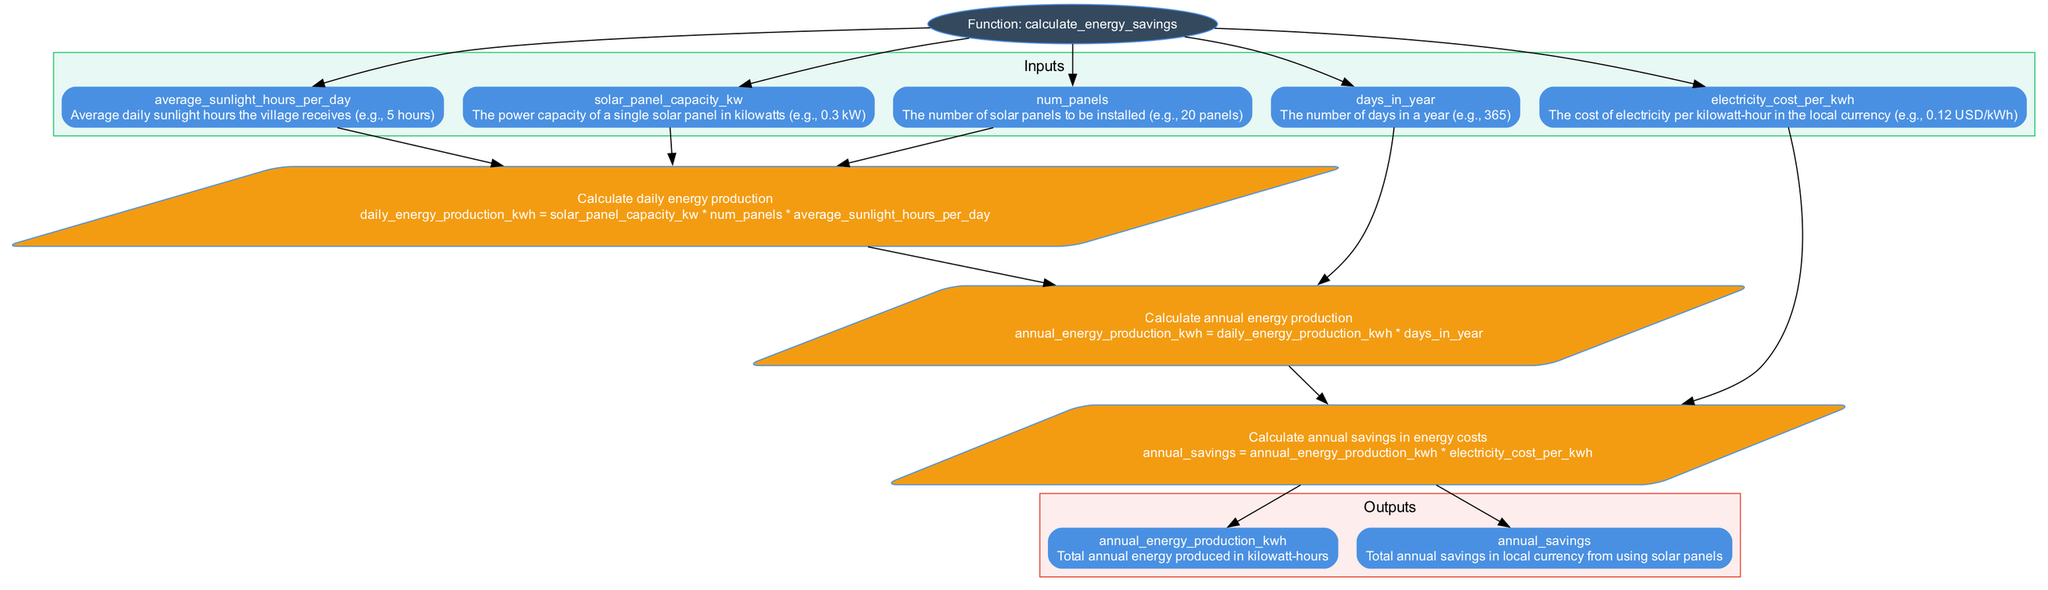What is the name of the function in the diagram? The function is named "calculate_energy_savings" as indicated in the top node of the diagram.
Answer: calculate_energy_savings How many inputs does the function have? The diagram has five input nodes listed which are solar panel capacity, number of panels, average sunlight hours per day, electricity cost per kWh, and days in a year. Therefore, the total count is five.
Answer: 5 What is the formula used to calculate daily energy production? The formula for calculating daily energy production is provided in the step 1 section, which is "daily_energy_production_kwh = solar_panel_capacity_kw * num_panels * average_sunlight_hours_per_day."
Answer: daily_energy_production_kwh = solar_panel_capacity_kw * num_panels * average_sunlight_hours_per_day Which input is directly connected to the calculation of annual savings? The input connected to the calculation of annual savings in step 3 is "electricity_cost_per_kwh." This is explicitly noted in the flowchart connections.
Answer: electricity_cost_per_kwh How many outputs are generated from the function? There are two output nodes in the diagram: annual energy production in kilowatt-hours and annual savings in local currency, indicating a total of two outputs.
Answer: 2 What step follows after the calculation of daily energy production? After the calculation of daily energy production, the next step is the calculation of annual energy production, as indicated by the flow of connections in the diagram.
Answer: calculation of annual energy production What operation is performed after calculating annual energy production? Following the calculation of annual energy production, the next operation performed is the calculation of annual savings, according to the sequential steps illustrated in the diagram.
Answer: calculation of annual savings What does the diagram visually represent? The diagram visually represents the process of a Python function that calculates energy savings from solar panels through defined inputs, calculations, and outputs.
Answer: a Python function for calculating energy savings from solar panels 